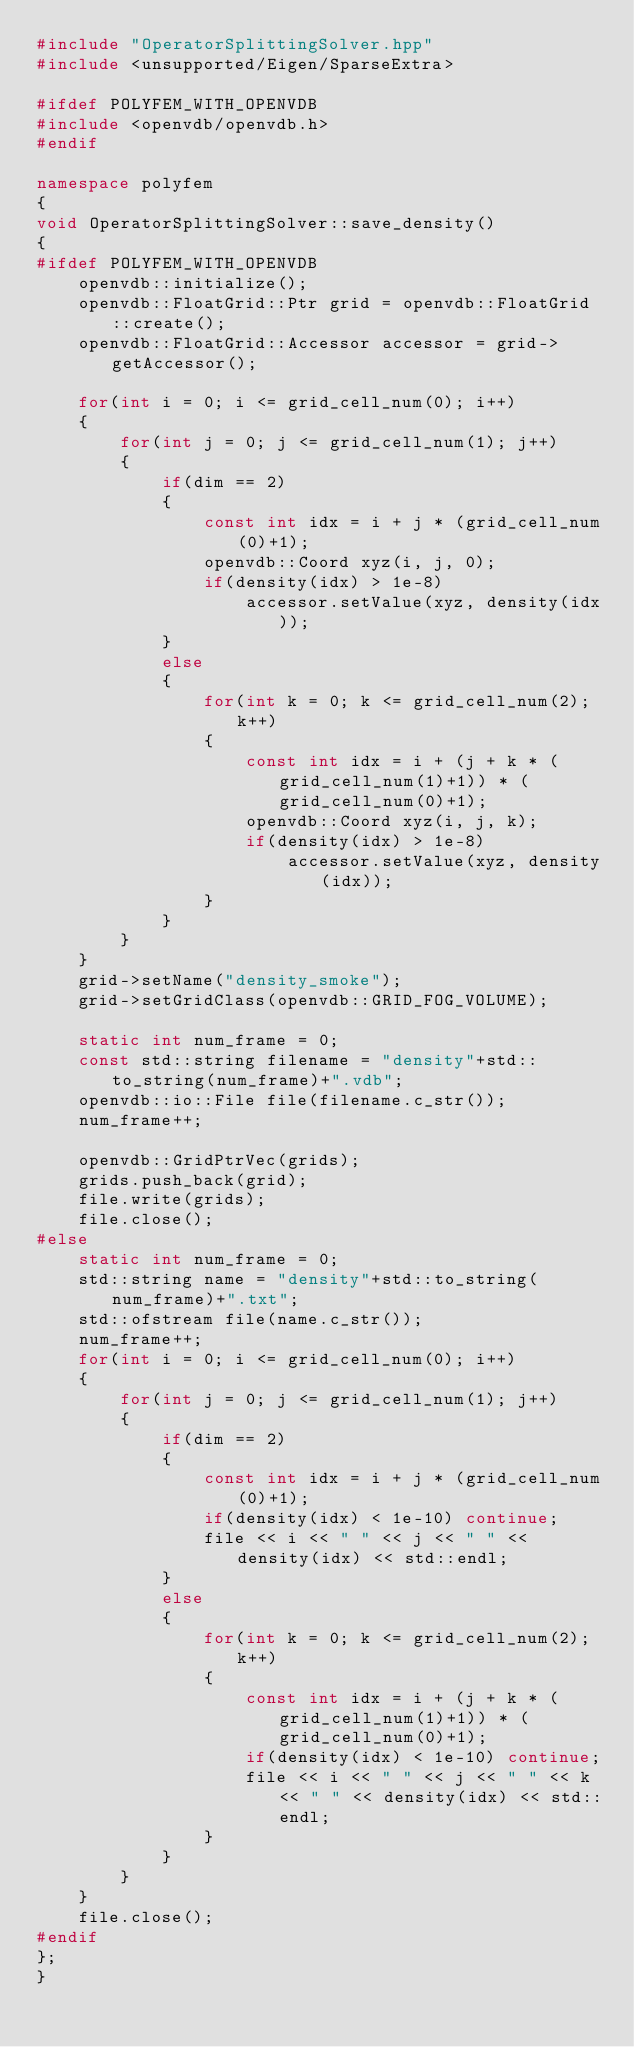Convert code to text. <code><loc_0><loc_0><loc_500><loc_500><_C++_>#include "OperatorSplittingSolver.hpp"
#include <unsupported/Eigen/SparseExtra>

#ifdef POLYFEM_WITH_OPENVDB
#include <openvdb/openvdb.h>
#endif

namespace polyfem
{
void OperatorSplittingSolver::save_density()
{
#ifdef POLYFEM_WITH_OPENVDB
    openvdb::initialize();
    openvdb::FloatGrid::Ptr grid = openvdb::FloatGrid::create();
    openvdb::FloatGrid::Accessor accessor = grid->getAccessor();

    for(int i = 0; i <= grid_cell_num(0); i++)
    {
        for(int j = 0; j <= grid_cell_num(1); j++)
        {
            if(dim == 2)
            {
                const int idx = i + j * (grid_cell_num(0)+1);
                openvdb::Coord xyz(i, j, 0);
                if(density(idx) > 1e-8)
                    accessor.setValue(xyz, density(idx));
            }
            else
            {
                for(int k = 0; k <= grid_cell_num(2); k++)
                {
                    const int idx = i + (j + k * (grid_cell_num(1)+1)) * (grid_cell_num(0)+1);
                    openvdb::Coord xyz(i, j, k);
                    if(density(idx) > 1e-8)
                        accessor.setValue(xyz, density(idx));
                }
            }
        }
    }
    grid->setName("density_smoke");
    grid->setGridClass(openvdb::GRID_FOG_VOLUME);

    static int num_frame = 0;
    const std::string filename = "density"+std::to_string(num_frame)+".vdb";
    openvdb::io::File file(filename.c_str());
    num_frame++;

    openvdb::GridPtrVec(grids);
    grids.push_back(grid);
    file.write(grids);
    file.close();
#else
    static int num_frame = 0;
    std::string name = "density"+std::to_string(num_frame)+".txt";
    std::ofstream file(name.c_str());
    num_frame++;
    for(int i = 0; i <= grid_cell_num(0); i++)
    {
        for(int j = 0; j <= grid_cell_num(1); j++)
        {
            if(dim == 2)
            {
                const int idx = i + j * (grid_cell_num(0)+1);
                if(density(idx) < 1e-10) continue;
                file << i << " " << j << " " << density(idx) << std::endl;
            }
            else
            {
                for(int k = 0; k <= grid_cell_num(2); k++)
                {
                    const int idx = i + (j + k * (grid_cell_num(1)+1)) * (grid_cell_num(0)+1);
                    if(density(idx) < 1e-10) continue;
                    file << i << " " << j << " " << k << " " << density(idx) << std::endl;
                }
            }
        }
    }
    file.close();
#endif
};
}</code> 